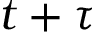Convert formula to latex. <formula><loc_0><loc_0><loc_500><loc_500>t + \tau</formula> 